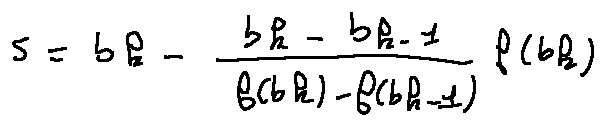<formula> <loc_0><loc_0><loc_500><loc_500>s = b _ { k } - \frac { b _ { k } - b _ { k - 1 } } { f ( b _ { k } ) - f ( b _ { k - 1 } ) } f ( b _ { k } )</formula> 